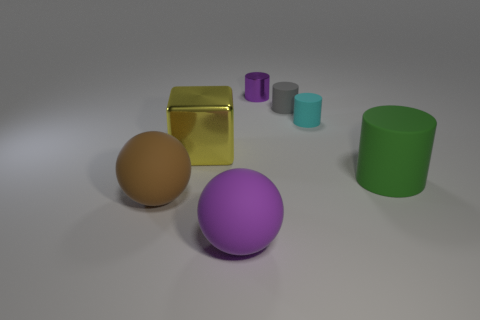There is a large rubber object right of the cyan matte cylinder; does it have the same shape as the purple object that is behind the big rubber cylinder?
Your answer should be compact. Yes. What number of balls are there?
Provide a succinct answer. 2. What is the shape of the big yellow object that is the same material as the purple cylinder?
Provide a succinct answer. Cube. Is there any other thing that has the same color as the large cube?
Your response must be concise. No. Do the tiny metal cylinder and the sphere that is right of the yellow cube have the same color?
Provide a succinct answer. Yes. Are there fewer tiny purple objects that are to the right of the tiny cyan matte thing than big shiny objects?
Offer a terse response. Yes. What material is the big ball that is in front of the big brown thing?
Your response must be concise. Rubber. How many other things are there of the same size as the purple cylinder?
Offer a very short reply. 2. There is a brown thing; is it the same size as the cylinder to the left of the gray cylinder?
Offer a very short reply. No. What is the shape of the small purple thing that is to the left of the small cyan cylinder to the right of the shiny thing behind the cyan thing?
Ensure brevity in your answer.  Cylinder. 